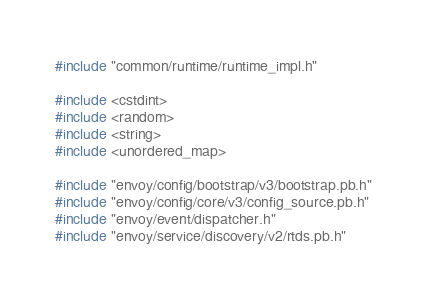<code> <loc_0><loc_0><loc_500><loc_500><_C++_>#include "common/runtime/runtime_impl.h"

#include <cstdint>
#include <random>
#include <string>
#include <unordered_map>

#include "envoy/config/bootstrap/v3/bootstrap.pb.h"
#include "envoy/config/core/v3/config_source.pb.h"
#include "envoy/event/dispatcher.h"
#include "envoy/service/discovery/v2/rtds.pb.h"</code> 